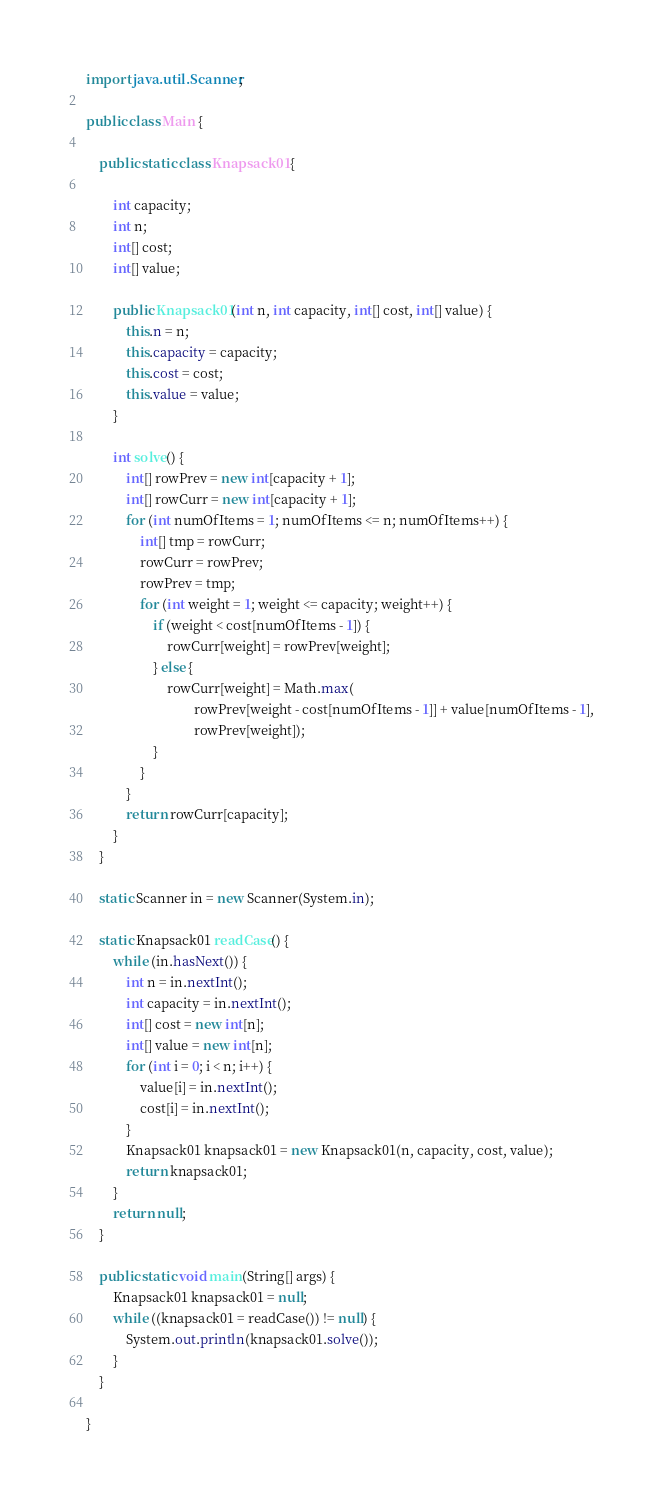Convert code to text. <code><loc_0><loc_0><loc_500><loc_500><_Java_>
import java.util.Scanner;

public class Main {

    public static class Knapsack01 {

        int capacity;
        int n;
        int[] cost;
        int[] value;

        public Knapsack01(int n, int capacity, int[] cost, int[] value) {
            this.n = n;
            this.capacity = capacity;
            this.cost = cost;
            this.value = value;
        }

        int solve() {
            int[] rowPrev = new int[capacity + 1];
            int[] rowCurr = new int[capacity + 1];
            for (int numOfItems = 1; numOfItems <= n; numOfItems++) {
                int[] tmp = rowCurr;
                rowCurr = rowPrev;
                rowPrev = tmp;
                for (int weight = 1; weight <= capacity; weight++) {
                    if (weight < cost[numOfItems - 1]) {
                        rowCurr[weight] = rowPrev[weight];
                    } else {
                        rowCurr[weight] = Math.max(
                                rowPrev[weight - cost[numOfItems - 1]] + value[numOfItems - 1],
                                rowPrev[weight]);
                    }
                }
            }
            return rowCurr[capacity];
        }
    }

    static Scanner in = new Scanner(System.in);

    static Knapsack01 readCase() {
        while (in.hasNext()) {
            int n = in.nextInt();
            int capacity = in.nextInt();
            int[] cost = new int[n];
            int[] value = new int[n];
            for (int i = 0; i < n; i++) {
                value[i] = in.nextInt();
                cost[i] = in.nextInt();
            }
            Knapsack01 knapsack01 = new Knapsack01(n, capacity, cost, value);
            return knapsack01;
        }
        return null;
    }

    public static void main(String[] args) {
        Knapsack01 knapsack01 = null;
        while ((knapsack01 = readCase()) != null) {
            System.out.println(knapsack01.solve());
        }
    }

}</code> 